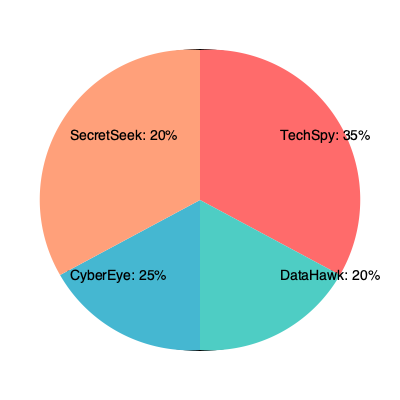Based on the pie chart showing market share of competing industrial espionage companies, which two companies combined have the largest market share, and what percentage of the market do they control together? To answer this question, we need to follow these steps:

1. Identify the market share percentages for each company:
   - TechSpy: 35%
   - DataHawk: 20%
   - CyberEye: 25%
   - SecretSeek: 20%

2. Determine which two companies have the largest individual market shares:
   - TechSpy (35%) and CyberEye (25%) have the largest individual shares.

3. Calculate the combined market share of these two companies:
   $35\% + 25\% = 60\%$

Therefore, TechSpy and CyberEye together control 60% of the market, which is the largest combined share among any two companies in the pie chart.
Answer: TechSpy and CyberEye, 60% 